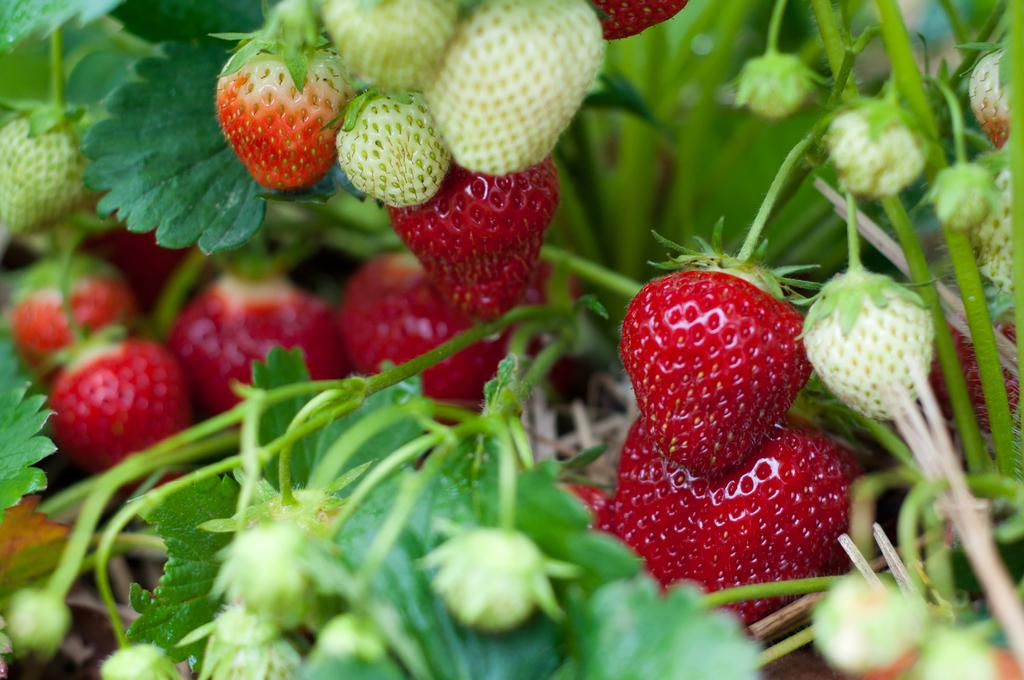What type of fruit is visible in the image? There is a group of strawberries in the image. What else can be seen in the image besides the strawberries? There are plants in the image. What type of fish is swimming in the hat in the image? There is no fish or hat present in the image; it only features a group of strawberries and plants. 